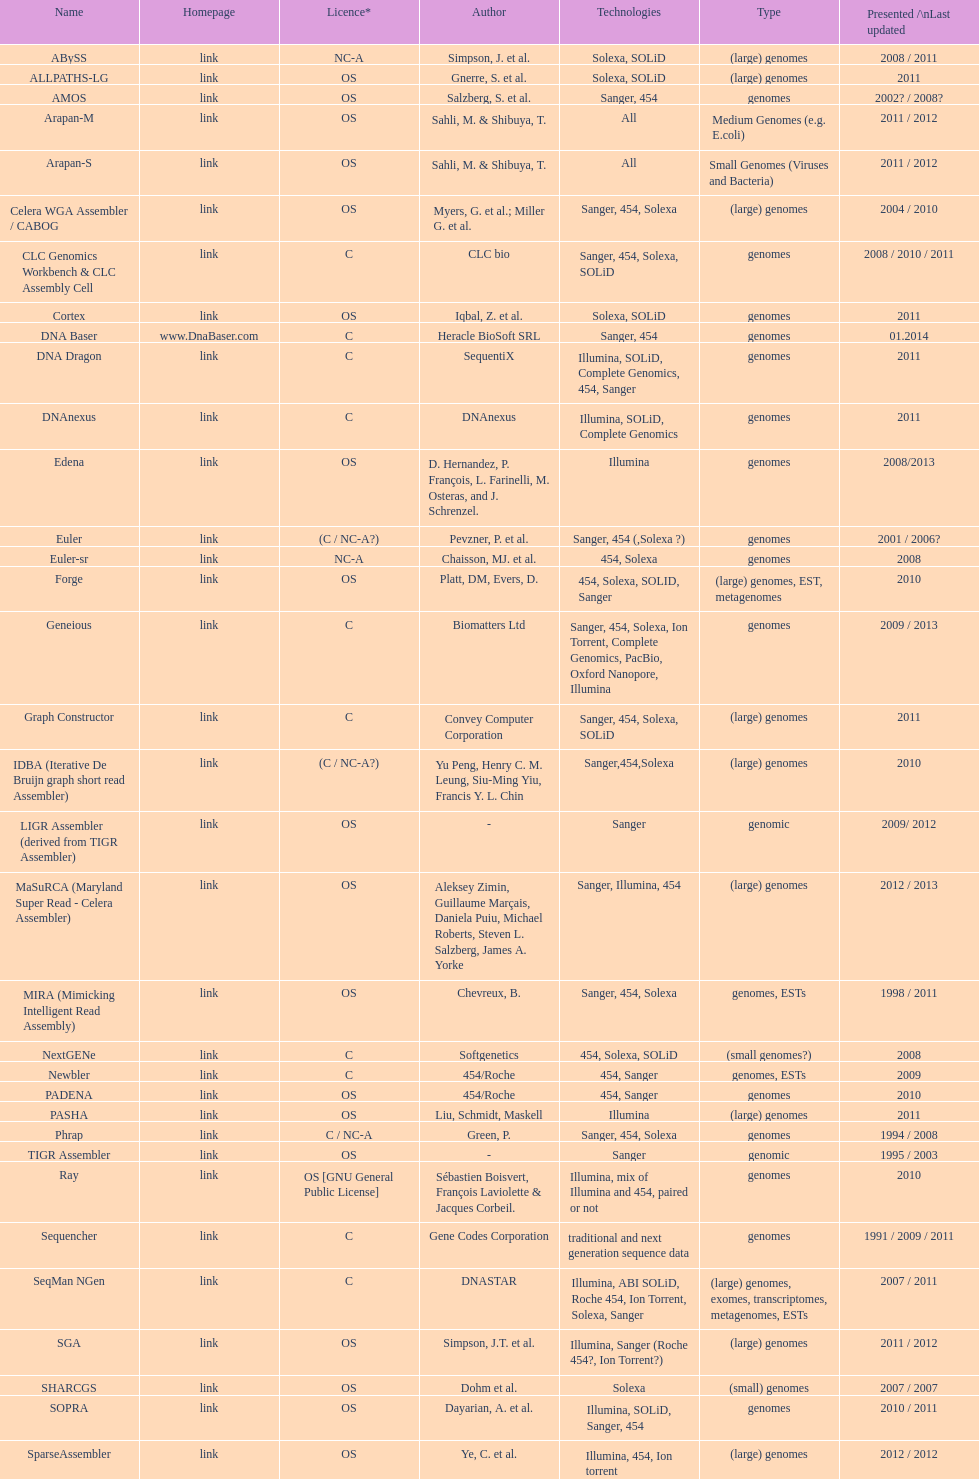When was the most recent update to the velvet? 2009. 